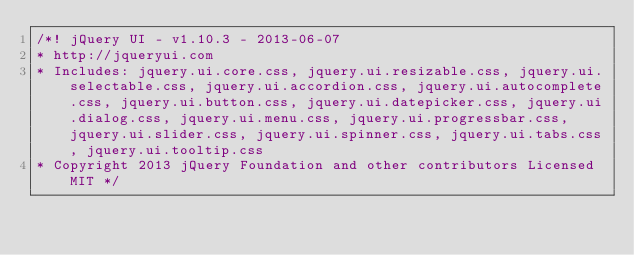Convert code to text. <code><loc_0><loc_0><loc_500><loc_500><_CSS_>/*! jQuery UI - v1.10.3 - 2013-06-07
* http://jqueryui.com
* Includes: jquery.ui.core.css, jquery.ui.resizable.css, jquery.ui.selectable.css, jquery.ui.accordion.css, jquery.ui.autocomplete.css, jquery.ui.button.css, jquery.ui.datepicker.css, jquery.ui.dialog.css, jquery.ui.menu.css, jquery.ui.progressbar.css, jquery.ui.slider.css, jquery.ui.spinner.css, jquery.ui.tabs.css, jquery.ui.tooltip.css
* Copyright 2013 jQuery Foundation and other contributors Licensed MIT */
</code> 